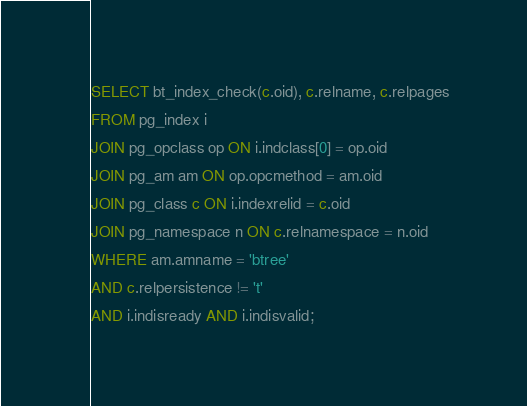<code> <loc_0><loc_0><loc_500><loc_500><_SQL_>SELECT bt_index_check(c.oid), c.relname, c.relpages
FROM pg_index i
JOIN pg_opclass op ON i.indclass[0] = op.oid
JOIN pg_am am ON op.opcmethod = am.oid
JOIN pg_class c ON i.indexrelid = c.oid
JOIN pg_namespace n ON c.relnamespace = n.oid
WHERE am.amname = 'btree'
AND c.relpersistence != 't'
AND i.indisready AND i.indisvalid;</code> 